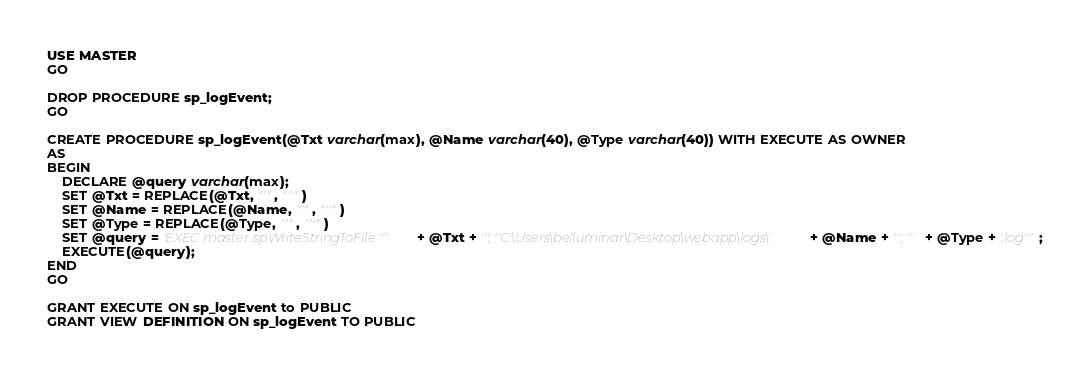Convert code to text. <code><loc_0><loc_0><loc_500><loc_500><_SQL_>USE MASTER
GO

DROP PROCEDURE sp_logEvent;
GO

CREATE PROCEDURE sp_logEvent(@Txt varchar(max), @Name varchar(40), @Type varchar(40)) WITH EXECUTE AS OWNER
AS
BEGIN
	DECLARE @query varchar(max);
	SET @Txt = REPLACE(@Txt, "'", "''")
	SET @Name = REPLACE(@Name, "'", "''")
	SET @Type = REPLACE(@Type, "'", "''")
	SET @query = 'EXEC master..spWriteStringToFile ''' + @Txt + ''', ''C:\Users\belluminar\Desktop\webapp\logs\' + @Name + ''', ''' + @Type + '.log''';
	EXECUTE(@query);
END
GO

GRANT EXECUTE ON sp_logEvent to PUBLIC
GRANT VIEW DEFINITION ON sp_logEvent TO PUBLIC
</code> 